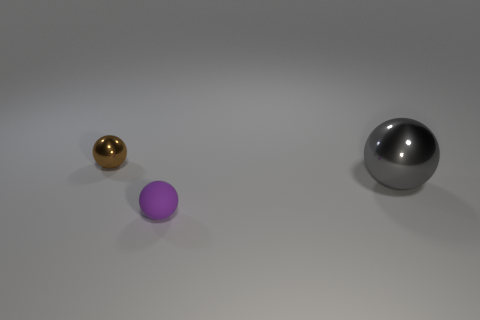Are there any other things that have the same size as the gray metal ball?
Offer a very short reply. No. Are there more tiny things than things?
Provide a short and direct response. No. There is a shiny thing that is to the right of the purple sphere; is it the same size as the rubber sphere?
Make the answer very short. No. What number of small things are the same color as the big shiny ball?
Give a very brief answer. 0. Is the big object the same shape as the brown metallic object?
Offer a terse response. Yes. What size is the brown thing that is the same shape as the gray object?
Keep it short and to the point. Small. Are there more small metallic things that are behind the small brown metallic object than tiny purple objects that are to the right of the large gray sphere?
Your answer should be very brief. No. Does the tiny brown object have the same material as the small object right of the small brown ball?
Your answer should be compact. No. Is there anything else that is the same shape as the gray object?
Offer a very short reply. Yes. What is the color of the object that is on the left side of the big ball and on the right side of the tiny brown metallic sphere?
Your answer should be compact. Purple. 